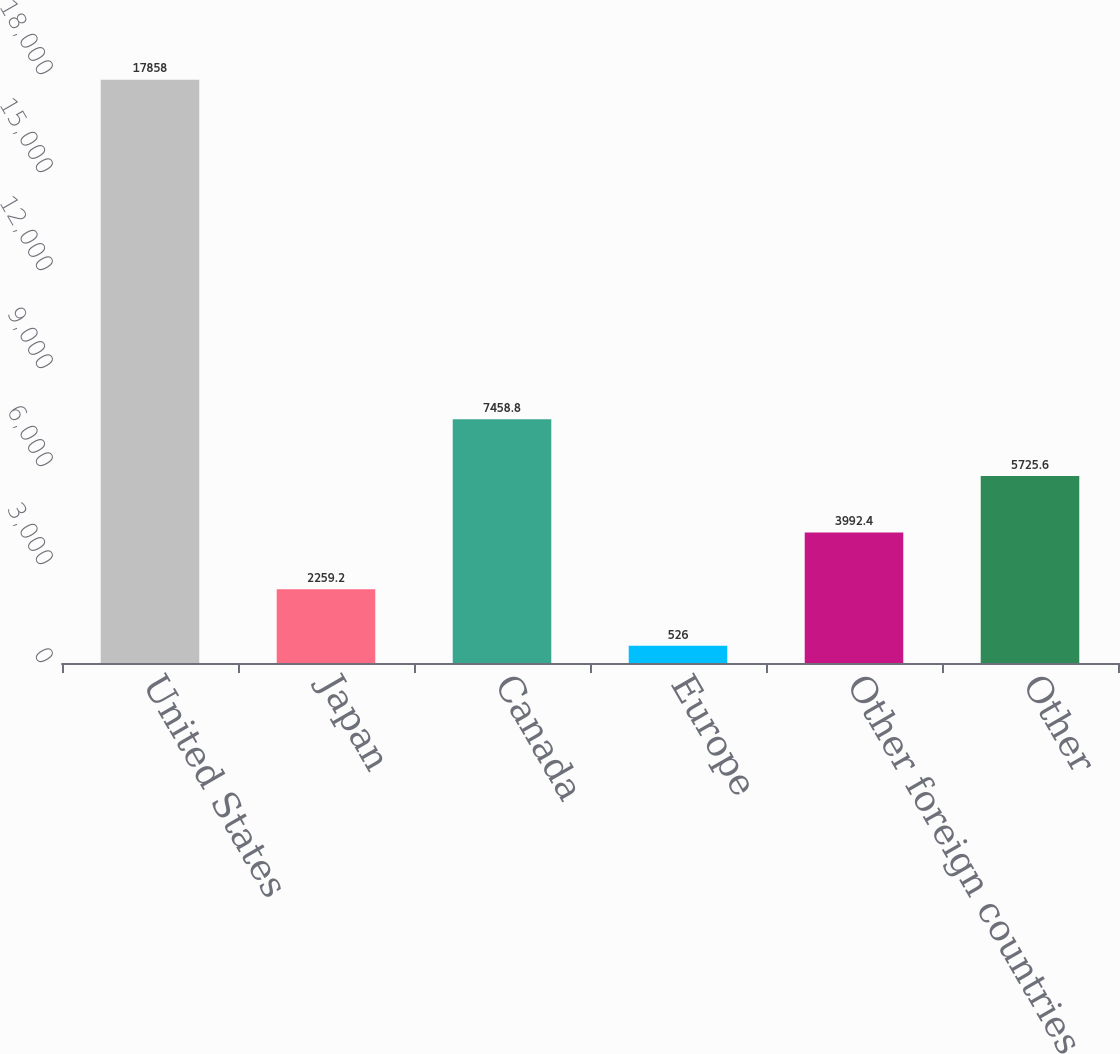Convert chart to OTSL. <chart><loc_0><loc_0><loc_500><loc_500><bar_chart><fcel>United States<fcel>Japan<fcel>Canada<fcel>Europe<fcel>Other foreign countries<fcel>Other<nl><fcel>17858<fcel>2259.2<fcel>7458.8<fcel>526<fcel>3992.4<fcel>5725.6<nl></chart> 